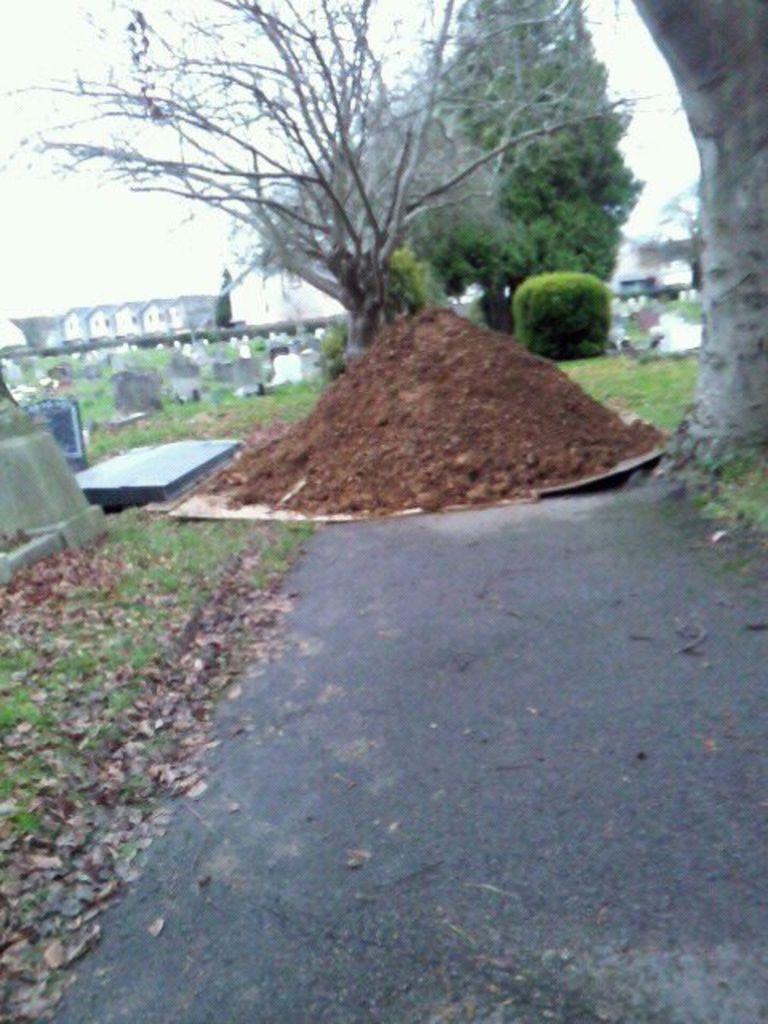Could you give a brief overview of what you see in this image? In this image we can see the heap of mud on the road. We can also see some plants, trees, stones, some dried leaves and the bark of a tree. On the backside we can see some houses with roof and the sky which looks cloudy. 